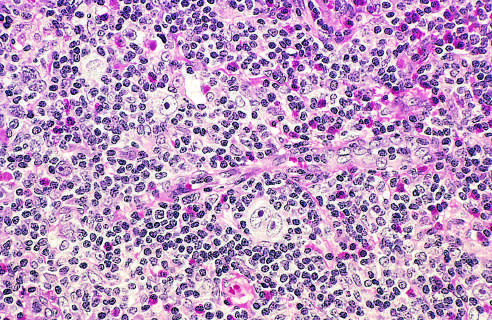what is a diagnostic, binucleate reed-sternberg cell surrounded by?
Answer the question using a single word or phrase. Eosinophils 